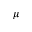<formula> <loc_0><loc_0><loc_500><loc_500>\mu</formula> 